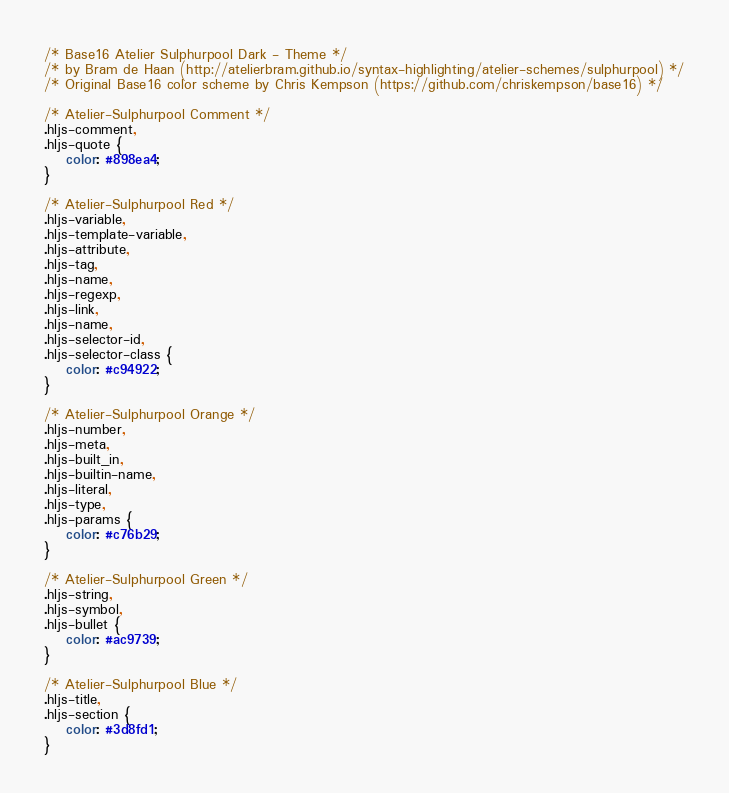Convert code to text. <code><loc_0><loc_0><loc_500><loc_500><_CSS_>/* Base16 Atelier Sulphurpool Dark - Theme */
/* by Bram de Haan (http://atelierbram.github.io/syntax-highlighting/atelier-schemes/sulphurpool) */
/* Original Base16 color scheme by Chris Kempson (https://github.com/chriskempson/base16) */

/* Atelier-Sulphurpool Comment */
.hljs-comment,
.hljs-quote {
	color: #898ea4;
}

/* Atelier-Sulphurpool Red */
.hljs-variable,
.hljs-template-variable,
.hljs-attribute,
.hljs-tag,
.hljs-name,
.hljs-regexp,
.hljs-link,
.hljs-name,
.hljs-selector-id,
.hljs-selector-class {
	color: #c94922;
}

/* Atelier-Sulphurpool Orange */
.hljs-number,
.hljs-meta,
.hljs-built_in,
.hljs-builtin-name,
.hljs-literal,
.hljs-type,
.hljs-params {
	color: #c76b29;
}

/* Atelier-Sulphurpool Green */
.hljs-string,
.hljs-symbol,
.hljs-bullet {
	color: #ac9739;
}

/* Atelier-Sulphurpool Blue */
.hljs-title,
.hljs-section {
	color: #3d8fd1;
}
</code> 